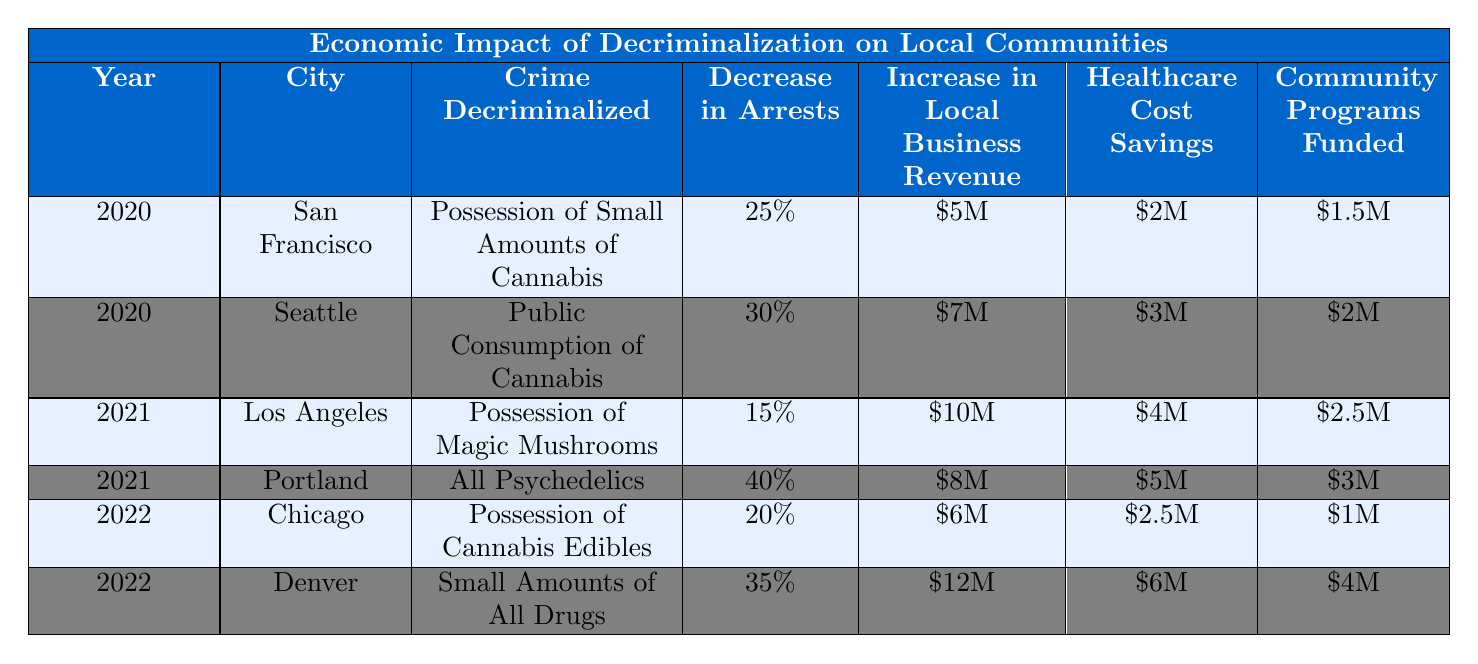What crime was decriminalized in Seattle in 2020? According to the table, the crime decriminalized in Seattle in 2020 was the public consumption of cannabis.
Answer: Public consumption of cannabis Which city had the highest increase in local business revenue in 2021? The table shows that Los Angeles had an increase of $10M in local business revenue in 2021, which is higher than Portland's $8M.
Answer: Los Angeles What was the decrease in arrests in Portland in 2021? The table indicates that the decrease in arrests in Portland in 2021 was 40%.
Answer: 40% What is the total amount of community programs funded across all cities for the year 2020? Summing the community programs funded: San Francisco ($1.5M) + Seattle ($2M) gives us a total of $3.5M.
Answer: $3.5M Which city in 2022 had the lowest decrease in arrests? The table shows that Chicago had a 20% decrease in arrests in 2022, which is lower than Denver's 35%.
Answer: Chicago What are the healthcare cost savings for Seattle in 2020 and how do they compare to those in Los Angeles in 2021? The healthcare cost savings for Seattle in 2020 were $3M, while for Los Angeles in 2021, they were $4M. Comparing these, Los Angeles had higher healthcare savings.
Answer: Seattle: $3M, Los Angeles: $4M How much more was the local business revenue in Denver in 2022 compared to Chicago in the same year? In Denver, the local business revenue was $12M and in Chicago, it was $6M. The difference is 12M - 6M = $6M more in Denver.
Answer: $6M Which city had the highest healthcare cost savings in 2022? The data shows that Denver had the highest healthcare cost savings in 2022 at $6M, compared to Chicago’s $2.5M.
Answer: Denver What percentage decrease in arrests was seen in Los Angeles compared to San Francisco in 2020? Los Angeles did not report any arrests in 2020, as it had no data for that year, so we cannot compare it directly to San Francisco’s 25% decrease. The question based on this information leads to no logical comparison.
Answer: Not applicable What was the average increase in local business revenue across the cities for the year 2021? For 2021, the increases in local business revenue were $10M (Los Angeles) and $8M (Portland). The average is calculated as (10 + 8) / 2 = $9M.
Answer: $9M Was there a decrease in arrests for all cities between the years 2020 and 2021? The table shows varying decreases; San Francisco had a 25% decrease and Seattle a 30% decrease in 2020, while Los Angeles had 15% and Portland 40% in 2021. Thus, the answer is no, as not all cities experienced this decrease trend.
Answer: No 